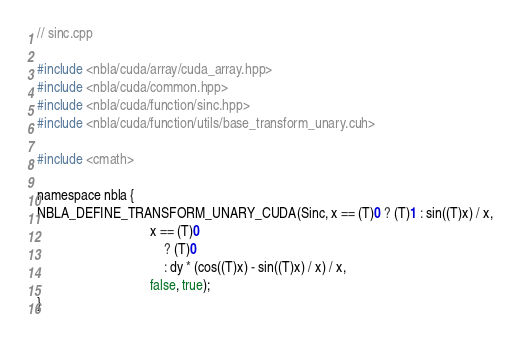<code> <loc_0><loc_0><loc_500><loc_500><_Cuda_>
// sinc.cpp

#include <nbla/cuda/array/cuda_array.hpp>
#include <nbla/cuda/common.hpp>
#include <nbla/cuda/function/sinc.hpp>
#include <nbla/cuda/function/utils/base_transform_unary.cuh>

#include <cmath>

namespace nbla {
NBLA_DEFINE_TRANSFORM_UNARY_CUDA(Sinc, x == (T)0 ? (T)1 : sin((T)x) / x,
                                 x == (T)0
                                     ? (T)0
                                     : dy * (cos((T)x) - sin((T)x) / x) / x,
                                 false, true);
}
</code> 